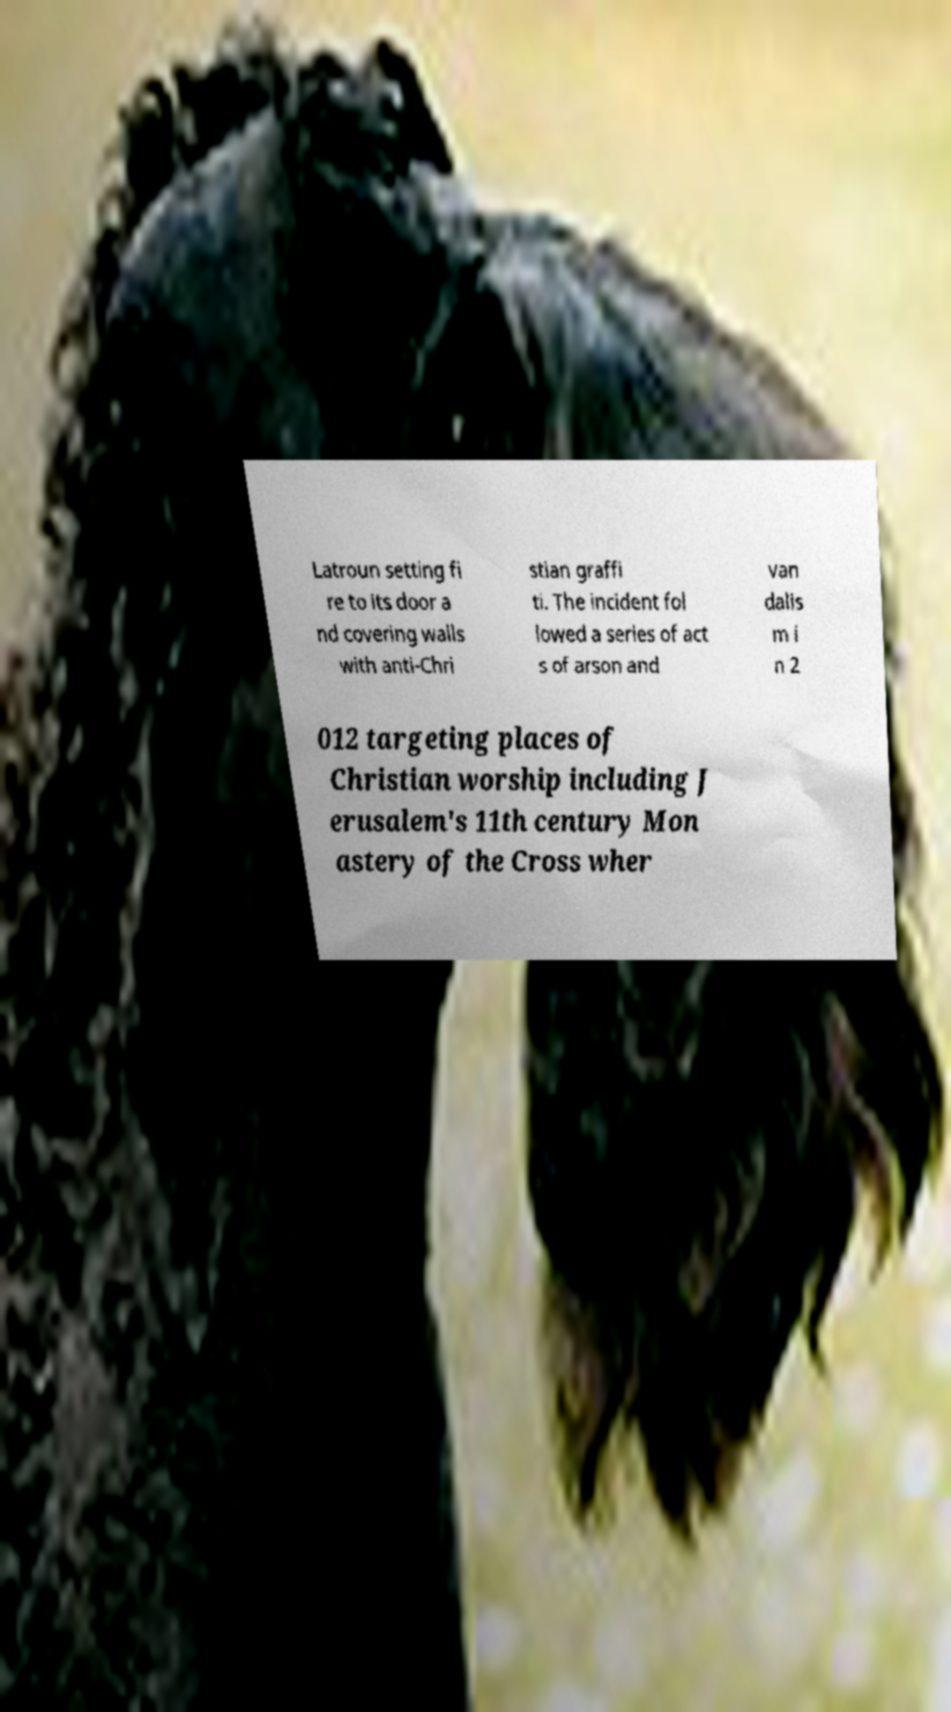Please identify and transcribe the text found in this image. Latroun setting fi re to its door a nd covering walls with anti-Chri stian graffi ti. The incident fol lowed a series of act s of arson and van dalis m i n 2 012 targeting places of Christian worship including J erusalem's 11th century Mon astery of the Cross wher 